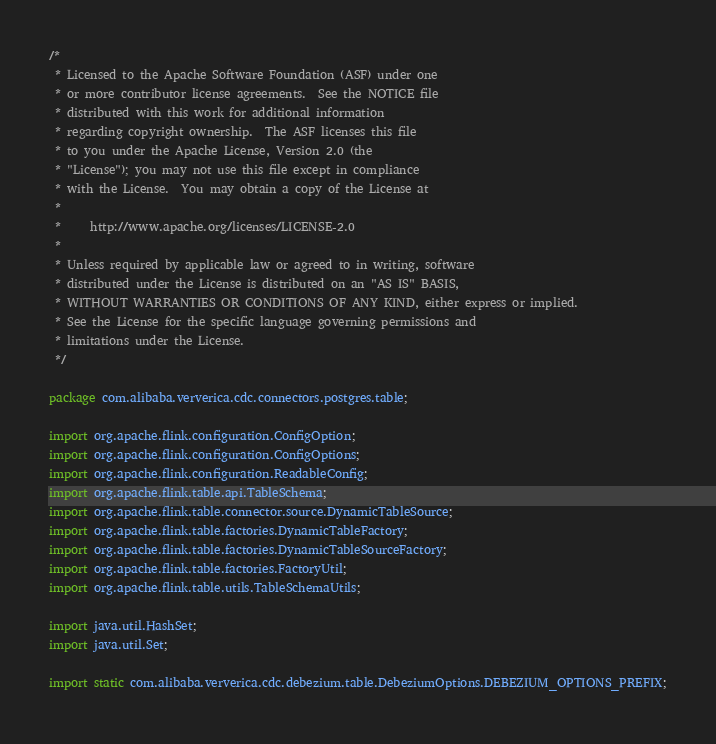Convert code to text. <code><loc_0><loc_0><loc_500><loc_500><_Java_>/*
 * Licensed to the Apache Software Foundation (ASF) under one
 * or more contributor license agreements.  See the NOTICE file
 * distributed with this work for additional information
 * regarding copyright ownership.  The ASF licenses this file
 * to you under the Apache License, Version 2.0 (the
 * "License"); you may not use this file except in compliance
 * with the License.  You may obtain a copy of the License at
 *
 *     http://www.apache.org/licenses/LICENSE-2.0
 *
 * Unless required by applicable law or agreed to in writing, software
 * distributed under the License is distributed on an "AS IS" BASIS,
 * WITHOUT WARRANTIES OR CONDITIONS OF ANY KIND, either express or implied.
 * See the License for the specific language governing permissions and
 * limitations under the License.
 */

package com.alibaba.ververica.cdc.connectors.postgres.table;

import org.apache.flink.configuration.ConfigOption;
import org.apache.flink.configuration.ConfigOptions;
import org.apache.flink.configuration.ReadableConfig;
import org.apache.flink.table.api.TableSchema;
import org.apache.flink.table.connector.source.DynamicTableSource;
import org.apache.flink.table.factories.DynamicTableFactory;
import org.apache.flink.table.factories.DynamicTableSourceFactory;
import org.apache.flink.table.factories.FactoryUtil;
import org.apache.flink.table.utils.TableSchemaUtils;

import java.util.HashSet;
import java.util.Set;

import static com.alibaba.ververica.cdc.debezium.table.DebeziumOptions.DEBEZIUM_OPTIONS_PREFIX;</code> 